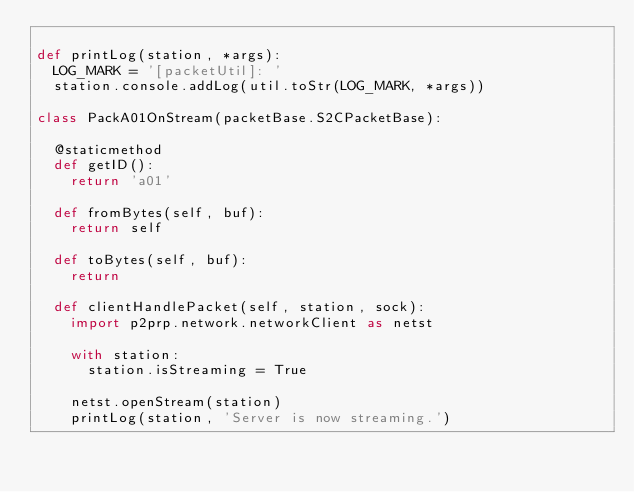<code> <loc_0><loc_0><loc_500><loc_500><_Python_>
def printLog(station, *args):
	LOG_MARK = '[packetUtil]: '
	station.console.addLog(util.toStr(LOG_MARK, *args))

class PackA01OnStream(packetBase.S2CPacketBase):
	
	@staticmethod
	def getID():
		return 'a01'
	
	def fromBytes(self, buf):
		return self
	
	def toBytes(self, buf):
		return
	
	def clientHandlePacket(self, station, sock):
		import p2prp.network.networkClient as netst
		
		with station:
			station.isStreaming = True
		
		netst.openStream(station)
		printLog(station, 'Server is now streaming.')</code> 